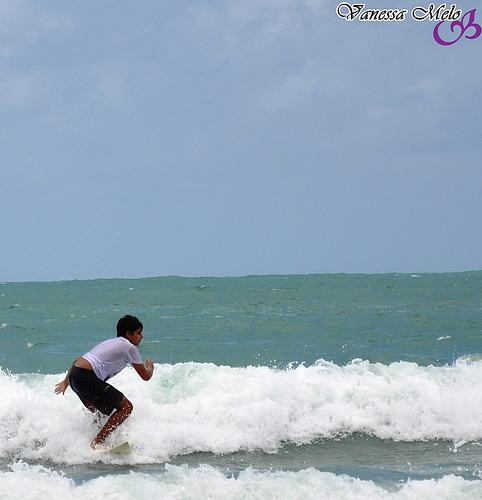Provide a brief and general description of the image. A young boy is surfing on a white surfboard in a calm blue ocean with small waves and clear sky. Use casual, colloquial language to describe the boy's actions and appearance in the image. This rad little dude is catching some chill vibes on his surfboard in the ocean, rockin' a wet white tee and black shorts with his black hair slicked back. Describe the ocean and the sky in the image. The ocean water looks calm with small ripples and waves, while the sky above is clear and open with wispy white clouds. Highlight the boy's outfit and physical appearance in the image. The boy has short dark hair, wearing a wet white t-shirt and black shorts, with his arm and hand visible. Use metaphorical language to describe the ocean, sky, and wave in the image. The serene blue ocean whispers tranquility, while the sky above unfurls like a vast canvas, adorned with whispers of thin clouds as the jubilant white sea foam dances with waves. Write a Haiku (5-7-5 syllable format) about the image. White sea foam does sway Create an acronym poem with the word SURF for the image. Fearless, the boy finds freedom. Write a sentence using alliteration to describe the image. A bright, brave boy balances on a big, buoyant, white surfboard amidst bubbly, beautiful blue ocean waves. Describe the image as if you were narrating it to a child. There's a brave young boy surfing in the big blue sea, riding on a white surfboard over gentle waves under a clean, open sky. Mention the boy's position on the surfboard and the wave in the image. The boy is standing on top of a large white surfboard, amid thick white sea foam crashing on a small wave near him. 